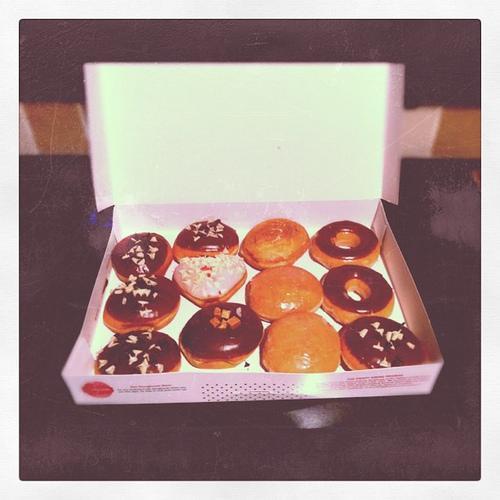How many doughnuts are there?
Give a very brief answer. 12. 